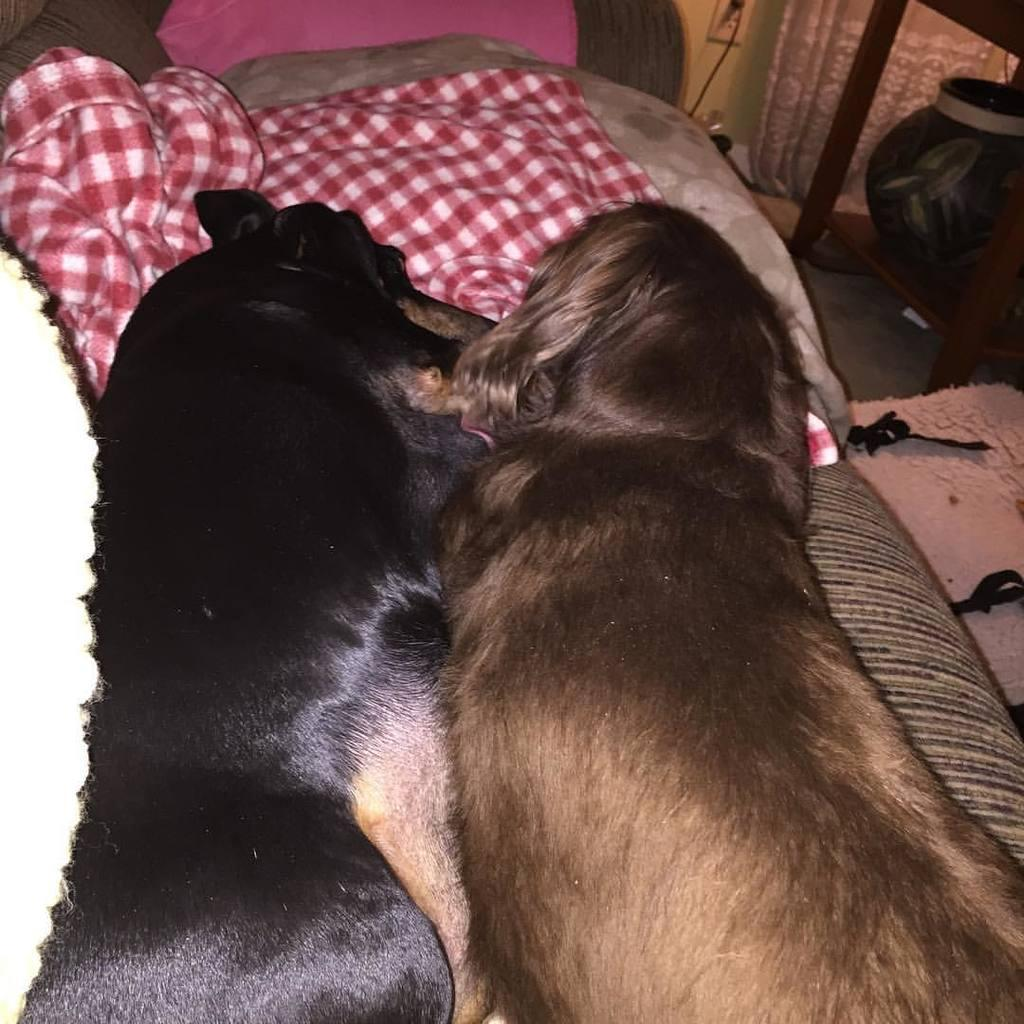How many dogs are in the image? There are two dogs in the image. What are the dogs doing in the image? The dogs are sleeping on a sofa. What is placed in front of the sofa? There is a pillow and a red color bed sheet in front of the sofa. Are there any other objects visible in the image? Yes, there are other objects in the right corner of the image. What type of pump can be seen in the image? There is no pump present in the image. Which side of the sofa are the dogs sleeping on? The dogs are sleeping on the sofa, so there is no specific side mentioned in the image. 